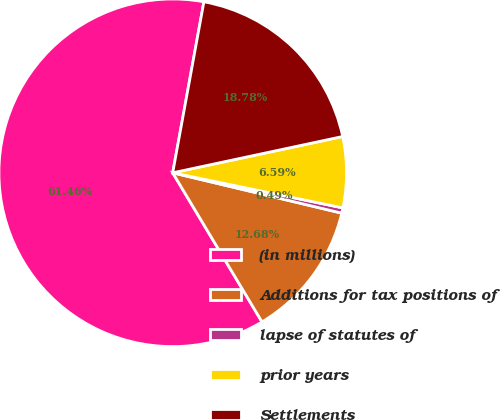<chart> <loc_0><loc_0><loc_500><loc_500><pie_chart><fcel>(in millions)<fcel>Additions for tax positions of<fcel>lapse of statutes of<fcel>prior years<fcel>Settlements<nl><fcel>61.46%<fcel>12.68%<fcel>0.49%<fcel>6.59%<fcel>18.78%<nl></chart> 